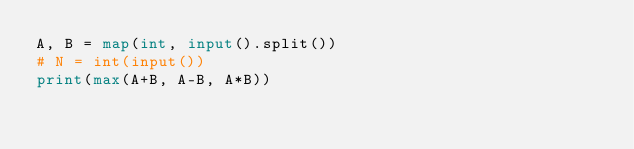<code> <loc_0><loc_0><loc_500><loc_500><_Python_>A, B = map(int, input().split())
# N = int(input())
print(max(A+B, A-B, A*B))</code> 